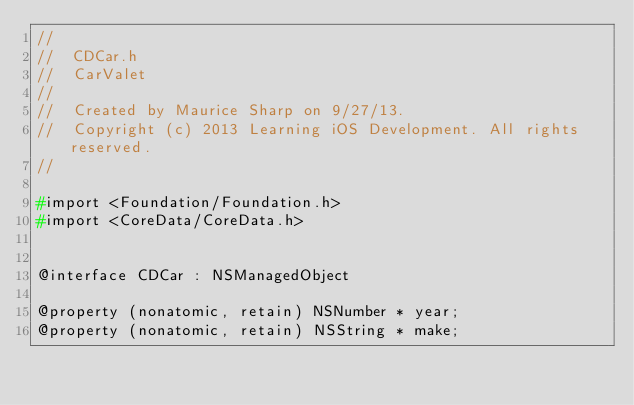<code> <loc_0><loc_0><loc_500><loc_500><_C_>//
//  CDCar.h
//  CarValet
//
//  Created by Maurice Sharp on 9/27/13.
//  Copyright (c) 2013 Learning iOS Development. All rights reserved.
//

#import <Foundation/Foundation.h>
#import <CoreData/CoreData.h>


@interface CDCar : NSManagedObject

@property (nonatomic, retain) NSNumber * year;
@property (nonatomic, retain) NSString * make;</code> 